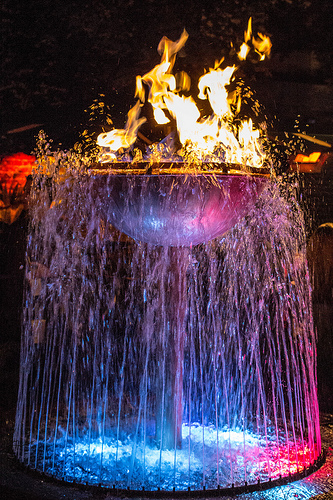<image>
Can you confirm if the fire is on the water? No. The fire is not positioned on the water. They may be near each other, but the fire is not supported by or resting on top of the water. 